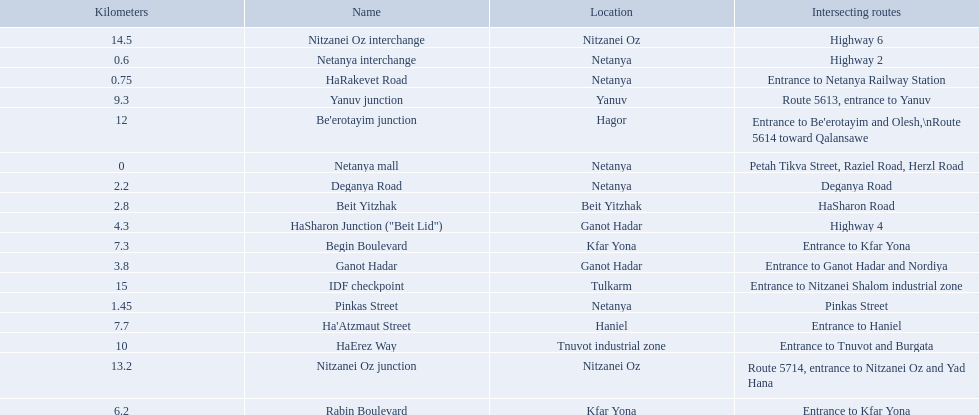What are all of the different portions? Netanya mall, Netanya interchange, HaRakevet Road, Pinkas Street, Deganya Road, Beit Yitzhak, Ganot Hadar, HaSharon Junction ("Beit Lid"), Rabin Boulevard, Begin Boulevard, Ha'Atzmaut Street, Yanuv junction, HaErez Way, Be'erotayim junction, Nitzanei Oz junction, Nitzanei Oz interchange, IDF checkpoint. What is the intersecting route for rabin boulevard? Entrance to Kfar Yona. What portion also has an intersecting route of entrance to kfar yona? Begin Boulevard. 